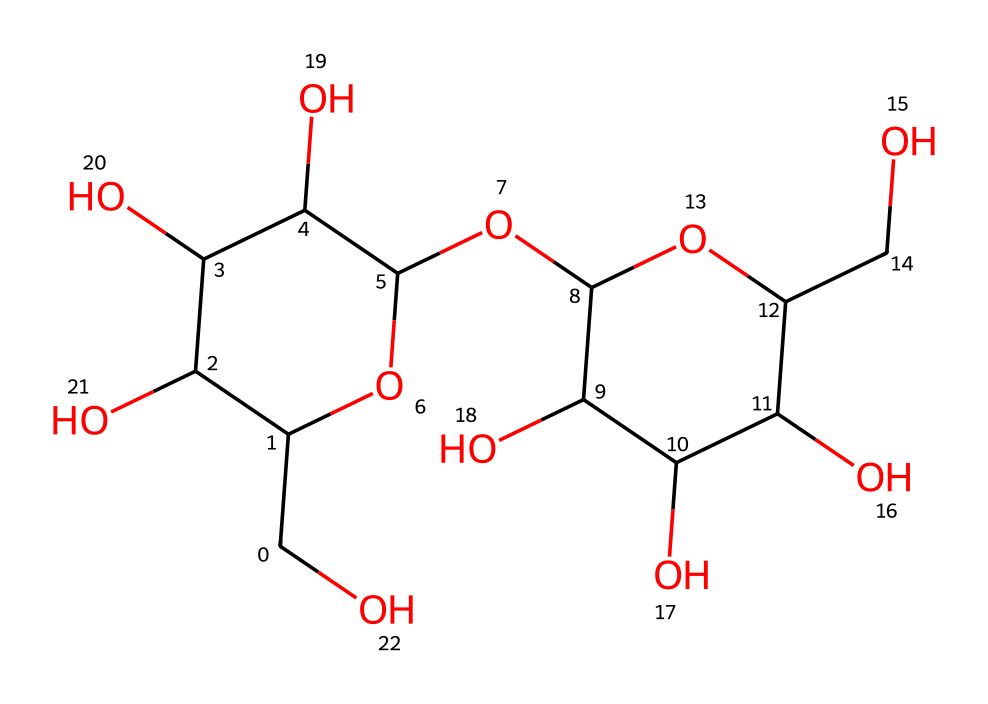What is the primary type of carbohydrate represented by this structure? The structure shown is of starch, which is a polysaccharide made up of many glucose units. Starch serves as a major energy storage form in plants.
Answer: polysaccharide How many oxygen atoms are in the structure? By counting the number of 'O' symbols in the SMILES representation, there are five oxygen atoms in the structure, indicating the presence of hydroxyl groups as well as ether linkages.
Answer: five What is the degree of polymerization of this starch? The number of glucose units, or the degree of polymerization, can be identified by counting the core cycle repetitions in the structure after analyzing the connections in the SMILES. In this case, the representation indicates multiple cyclical forms, suggesting a higher degree.
Answer: multiple Which functional groups are present in this structure? The structure includes hydroxyl (-OH) groups which are characteristic of many carbohydrates. They play a key role in their solubility and reactivity, essential for bioethanol production as well.
Answer: hydroxyl groups What does this chemical structure potentially indicate about its use in bioethanol production? The presence of many glucose units linked by glycosidic bonds indicates that it can be hydrolyzed into simpler sugars, which are the primary fermentable sugars needed for bioethanol production.
Answer: fermentable sugars 